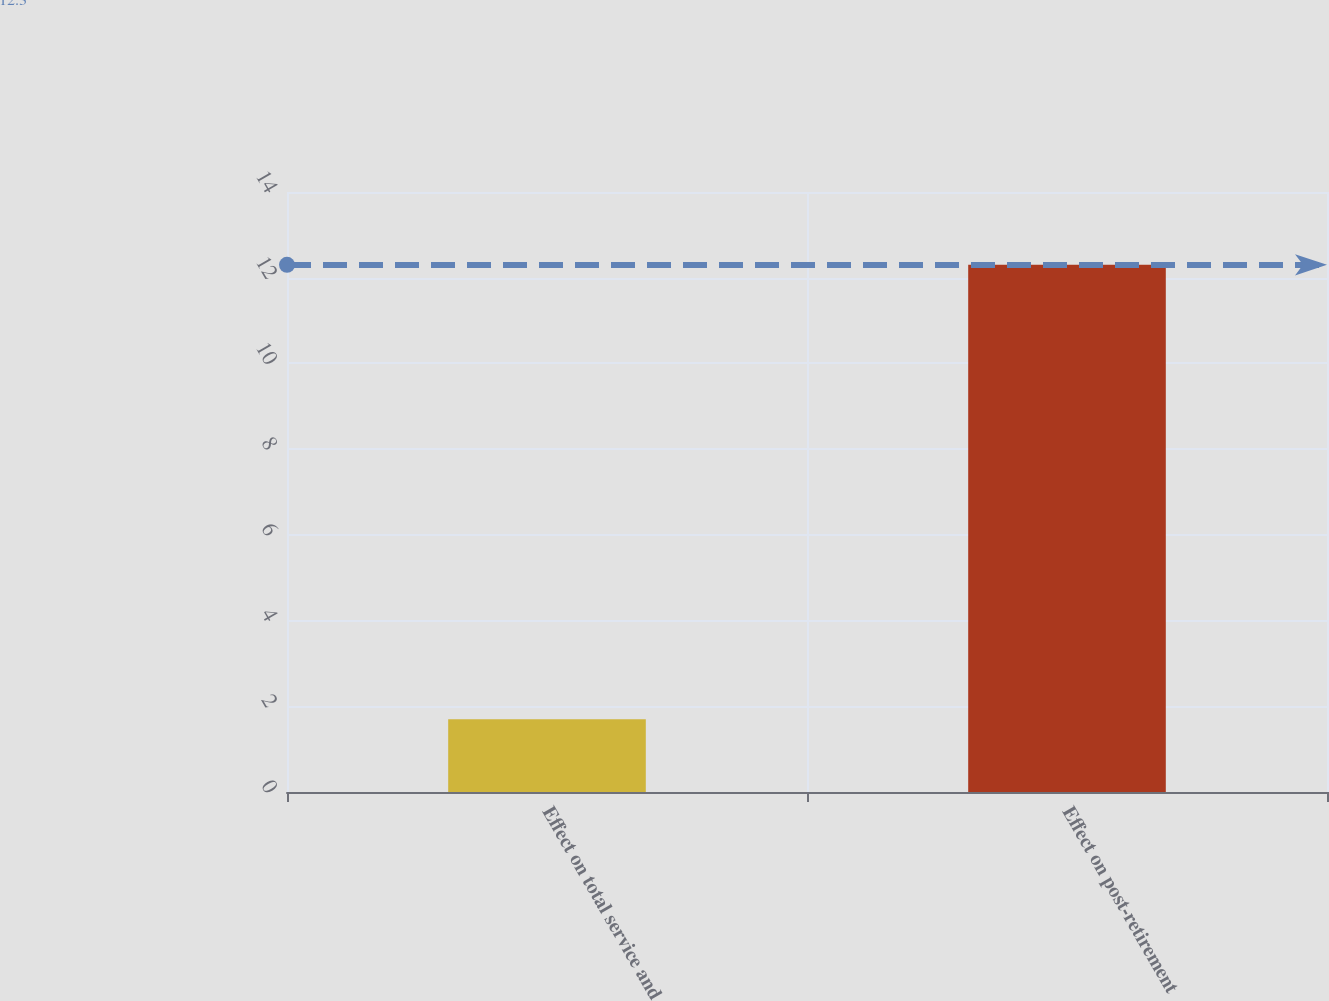Convert chart to OTSL. <chart><loc_0><loc_0><loc_500><loc_500><bar_chart><fcel>Effect on total service and<fcel>Effect on post-retirement<nl><fcel>1.7<fcel>12.3<nl></chart> 